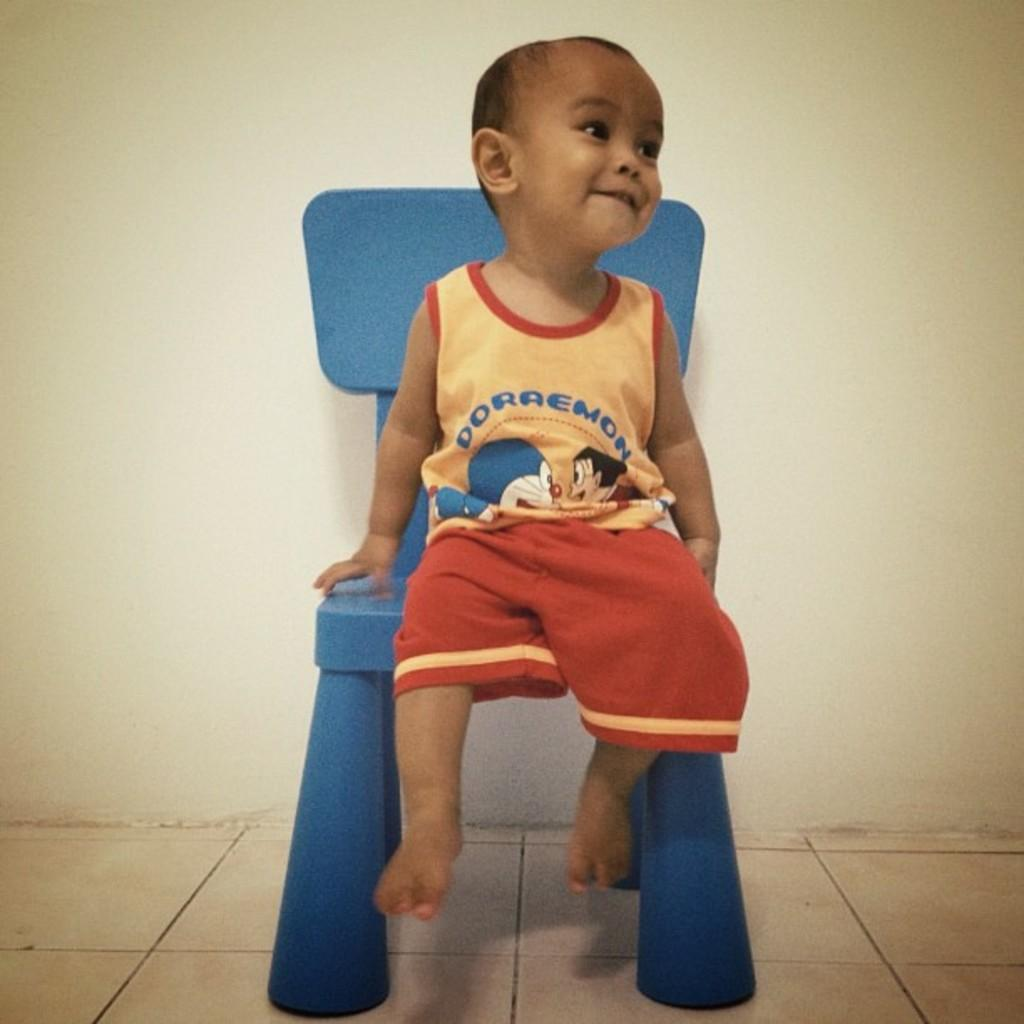What piece of furniture is present in the image? There is a chair in the image. Who is sitting on the chair? A child is sitting on the chair. What is the child wearing? The child is wearing a Doraemon shirt. What colors are present on the Doraemon shirt? The Doraemon shirt is yellow and red in color. What type of insurance policy does the child have in the image? There is no mention of insurance in the image, as it focuses on the chair, child, and Doraemon shirt. 